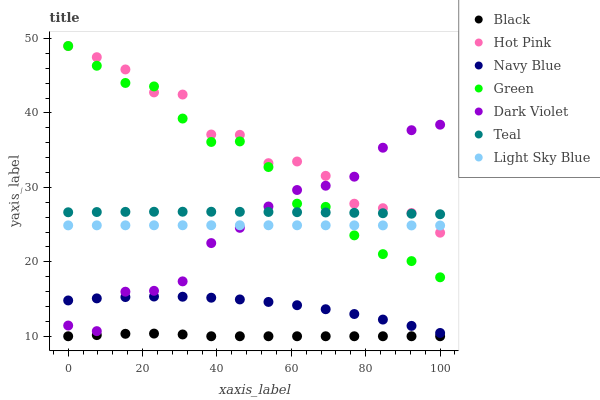Does Black have the minimum area under the curve?
Answer yes or no. Yes. Does Hot Pink have the maximum area under the curve?
Answer yes or no. Yes. Does Dark Violet have the minimum area under the curve?
Answer yes or no. No. Does Dark Violet have the maximum area under the curve?
Answer yes or no. No. Is Light Sky Blue the smoothest?
Answer yes or no. Yes. Is Hot Pink the roughest?
Answer yes or no. Yes. Is Dark Violet the smoothest?
Answer yes or no. No. Is Dark Violet the roughest?
Answer yes or no. No. Does Black have the lowest value?
Answer yes or no. Yes. Does Hot Pink have the lowest value?
Answer yes or no. No. Does Green have the highest value?
Answer yes or no. Yes. Does Dark Violet have the highest value?
Answer yes or no. No. Is Black less than Dark Violet?
Answer yes or no. Yes. Is Teal greater than Light Sky Blue?
Answer yes or no. Yes. Does Light Sky Blue intersect Dark Violet?
Answer yes or no. Yes. Is Light Sky Blue less than Dark Violet?
Answer yes or no. No. Is Light Sky Blue greater than Dark Violet?
Answer yes or no. No. Does Black intersect Dark Violet?
Answer yes or no. No. 